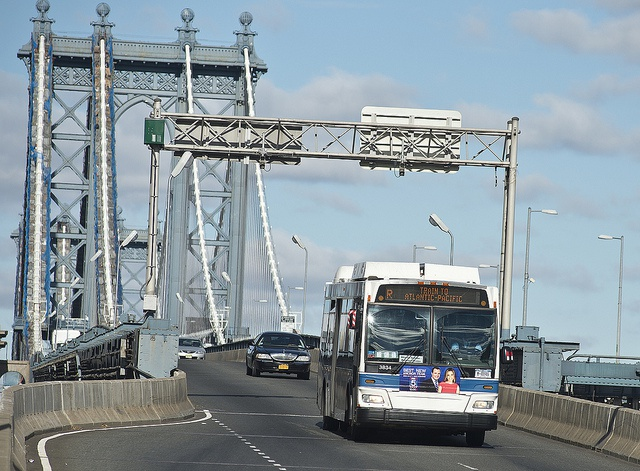Describe the objects in this image and their specific colors. I can see bus in darkgray, black, gray, and white tones, car in darkgray, black, and gray tones, and car in darkgray, black, gray, and white tones in this image. 